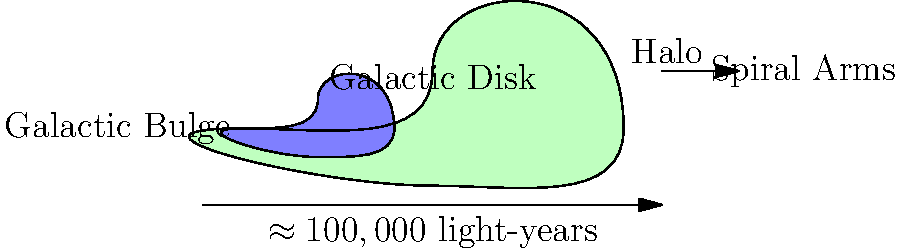Based on the diagram of the Milky Way galaxy's structure, which component is represented by the light blue region in the center, and what is its primary stellar population? To answer this question, let's analyze the diagram and recall our knowledge of galactic structure:

1. The diagram shows a cross-section of the Milky Way galaxy.
2. We can identify three main components:
   a) A large, flattened disk (pale green)
   b) A central, bulging region (light blue)
   c) A surrounding halo (unlabeled, but mentioned)

3. The light blue region in the center represents the Galactic Bulge.
4. The Galactic Bulge is characterized by its stellar population:
   - It primarily contains older, low-mass stars.
   - These stars are typically Population II stars, which are metal-poor and formed early in the galaxy's history.

5. Key characteristics of Population II stars in the bulge:
   - They are generally redder and cooler than the younger stars in the disk.
   - They have lower metallicity (lower abundance of elements heavier than helium).
   - Their orbits are more randomized, contributing to the spheroidal shape of the bulge.

6. The bulge's stellar population contrasts with the disk, which contains younger Population I stars and ongoing star formation in the spiral arms.

Therefore, the light blue region represents the Galactic Bulge, and its primary stellar population consists of older Population II stars.
Answer: Galactic Bulge; Population II stars 